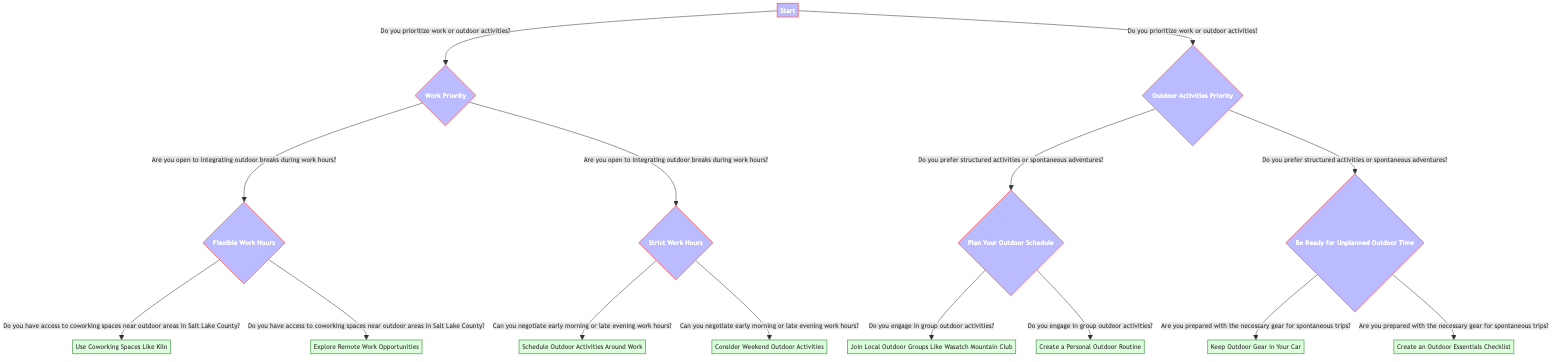What question is asked at the start of the decision tree? The decision tree starts by asking, "Do you prioritize work or outdoor activities?" This question determines the first branch of the flow, leading to either a focus on work or outdoor activities.
Answer: Do you prioritize work or outdoor activities? How many options are there under the 'Work Priority' node? Under the 'Work Priority' node, there are two options presented: "Yes" for integrating outdoor breaks and "No" for strict work hours. This indicates that there are two paths based on the response to the question regarding outdoor breaks.
Answer: 2 What is the next question after selecting "Be Ready for Unplanned Outdoor Time"? After selecting "Be Ready for Unplanned Outdoor Time," the next question asked is, "Are you prepared with the necessary gear for spontaneous trips?" This question assesses readiness for unplanned outdoor activities.
Answer: Are you prepared with the necessary gear for spontaneous trips? If someone engages in group outdoor activities, what should they do according to the diagram? If someone engages in group outdoor activities, they are advised to "Join Local Outdoor Groups Like Wasatch Mountain Club." This option is presented following the question about group activities under the "Plan Your Outdoor Schedule" node.
Answer: Join Local Outdoor Groups Like Wasatch Mountain Club What happens if the answer to "Are you open to integrating outdoor breaks during work hours?" is 'No'? If the answer to "Are you open to integrating outdoor breaks during work hours?" is 'No', the next question asked would be, "Can you negotiate early morning or late evening work hours?" This determines if the person can adjust their schedule to accommodate outdoor time around strict work hours.
Answer: Can you negotiate early morning or late evening work hours? 